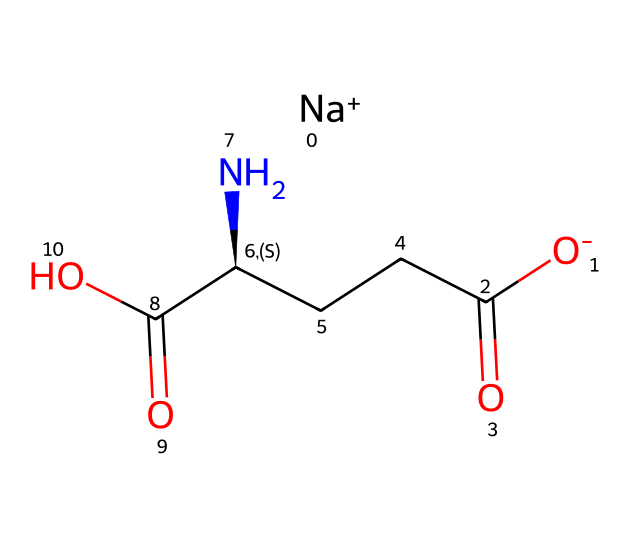What is the molecular formula of monosodium glutamate? The molecular formula can be derived from the structural formula by counting the number of each type of atom present in the structure. In this case, the structure contains one sodium atom (Na), one nitrogen atom (N), four carbon atoms (C), seven hydrogen atoms (H), and four oxygen atoms (O), leading to the formula C5H8NNaO4.
Answer: C5H8NNaO4 How many carbon atoms are present in the structure? By examining the SMILES representation, we identify the number of carbon atoms (C) indicated, corresponding to the structural components. There are four carbon atoms in MSG.
Answer: 4 What type of bond connects the nitrogen to the carbon chain? The nitrogen is bonded to the carbon backbone, which is typically through a single bond in amines. In the represented structure, the nitrogen is attached to a carbon via a single bond, making it an amine link.
Answer: single bond How many functional groups are present in monosodium glutamate? The structural representation indicates two carboxylic acid groups (due to the C(=O)O function) and one amine group (N). Therefore, counting those, we find there are three functional groups.
Answer: 3 What role does monosodium glutamate play in food? MSG is primarily used as a flavor enhancer. Its structure, particularly the amino acid component, contributes to umami taste, which is recognized in various cuisines. Hence, upon evaluating its function in culinary applications, it's categorized primarily as a flavor enhancer.
Answer: flavor enhancer What elements in MSG contribute to its ionic character? The presence of sodium (Na) and oxygen (O) within a carboxylate group contributes to MSG's ionic character. Specifically, the sodium ion (Na+) and the negative charge on one of the oxygen atoms ([O-]) indicate that it has ionic properties.
Answer: sodium and oxygen 